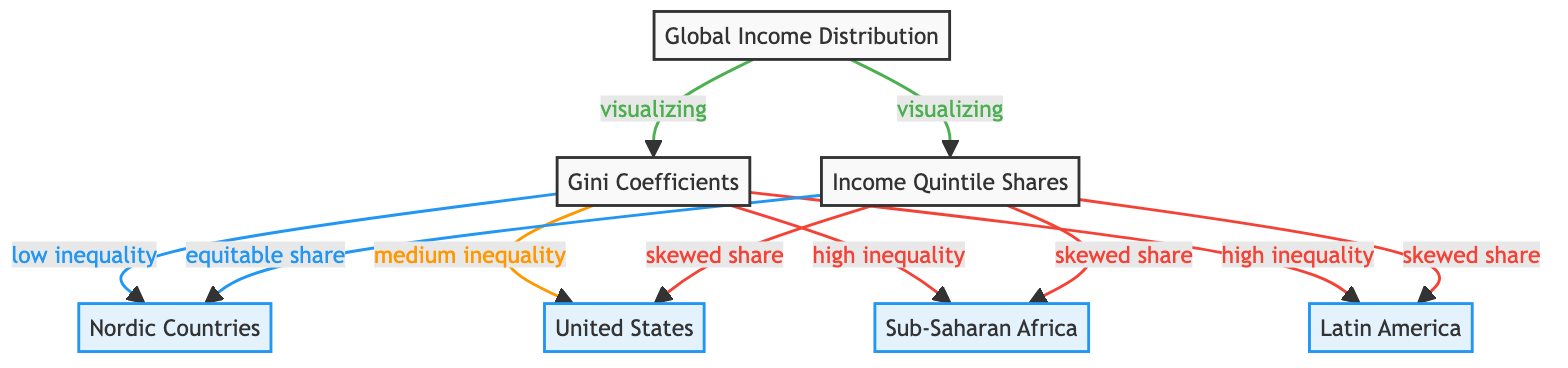What does the diagram visualize? The diagram visualizes Global Income Distribution through two main concepts: Gini coefficients and income quintile shares across various countries.
Answer: Global Income Distribution Which node represents low inequality? The node representing low inequality is connected to the Gini Coefficient and is labeled as "Nordic Countries."
Answer: Nordic Countries How many regions are represented in the diagram? The diagram features four regions, including Nordic Countries, United States, Sub-Saharan Africa, and Latin America.
Answer: Four What type of income share is associated with the United States? The income share associated with the United States is described as a "skewed share," indicating a significant income disparity.
Answer: Skewed share Which regions exhibit high inequality according to the diagram? The regions exhibiting high inequality are Sub-Saharan Africa and Latin America, as both are linked to the high Gini coefficients.
Answer: Sub-Saharan Africa and Latin America How does the diagram classify Nordic Countries in terms of income inequality? The diagram classifies Nordic Countries with a low Gini coefficient, indicating low income inequality, and describes their income share as equitable.
Answer: Low inequality and equitable share What visual connections are made between Gini coefficients and Income Quintile Shares? The connections indicate that low Gini coefficients lead to equitable shares, while medium to high Gini coefficients lead to skewed shares.
Answer: Low leads to equitable; Medium/High leads to skewed What is the primary purpose of this Social Science Diagram? The primary purpose of the diagram is to visualize and illustrate the relationship between income distribution metrics across various countries.
Answer: To visualize income distribution metrics 